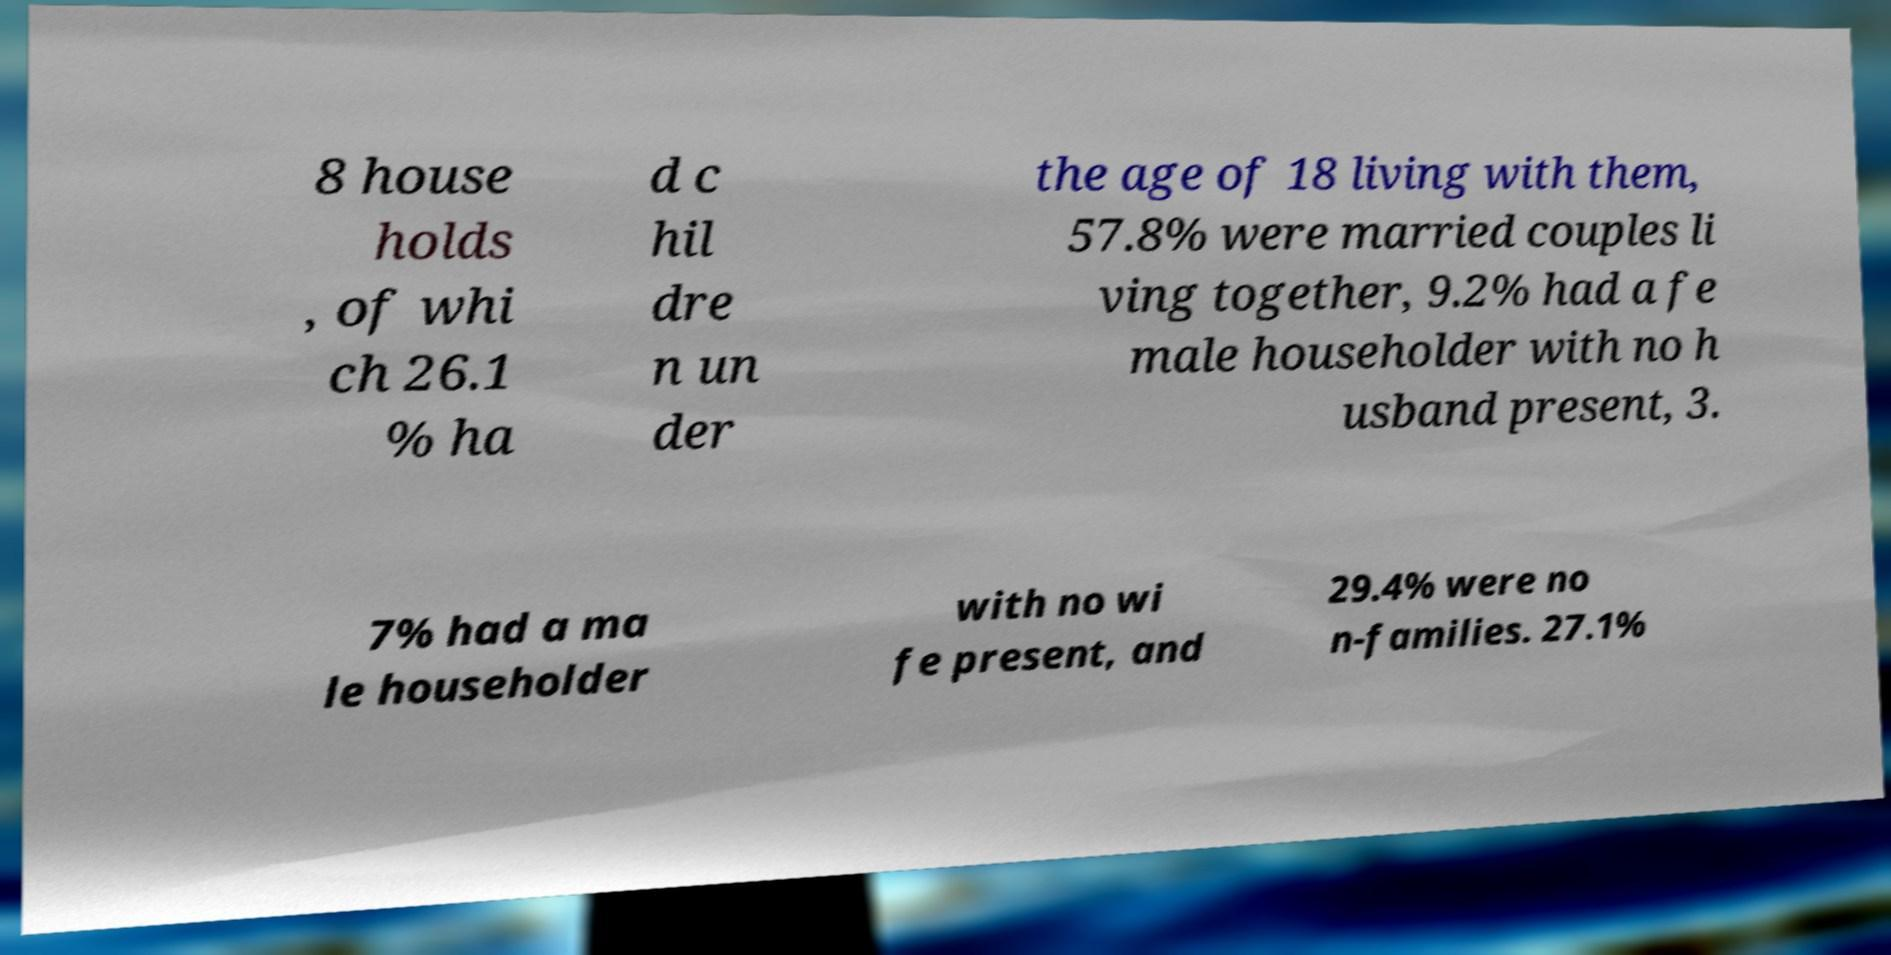There's text embedded in this image that I need extracted. Can you transcribe it verbatim? 8 house holds , of whi ch 26.1 % ha d c hil dre n un der the age of 18 living with them, 57.8% were married couples li ving together, 9.2% had a fe male householder with no h usband present, 3. 7% had a ma le householder with no wi fe present, and 29.4% were no n-families. 27.1% 